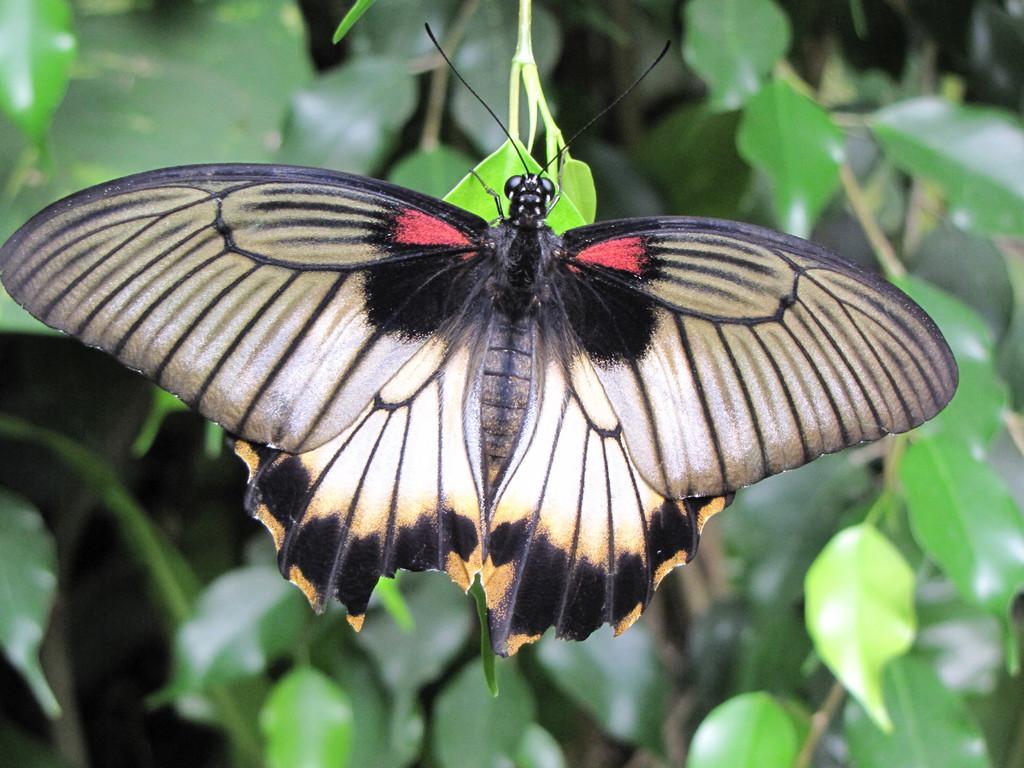Could you give a brief overview of what you see in this image? In this picture we can see a butterfly in the front, in the background there are some leaves. 